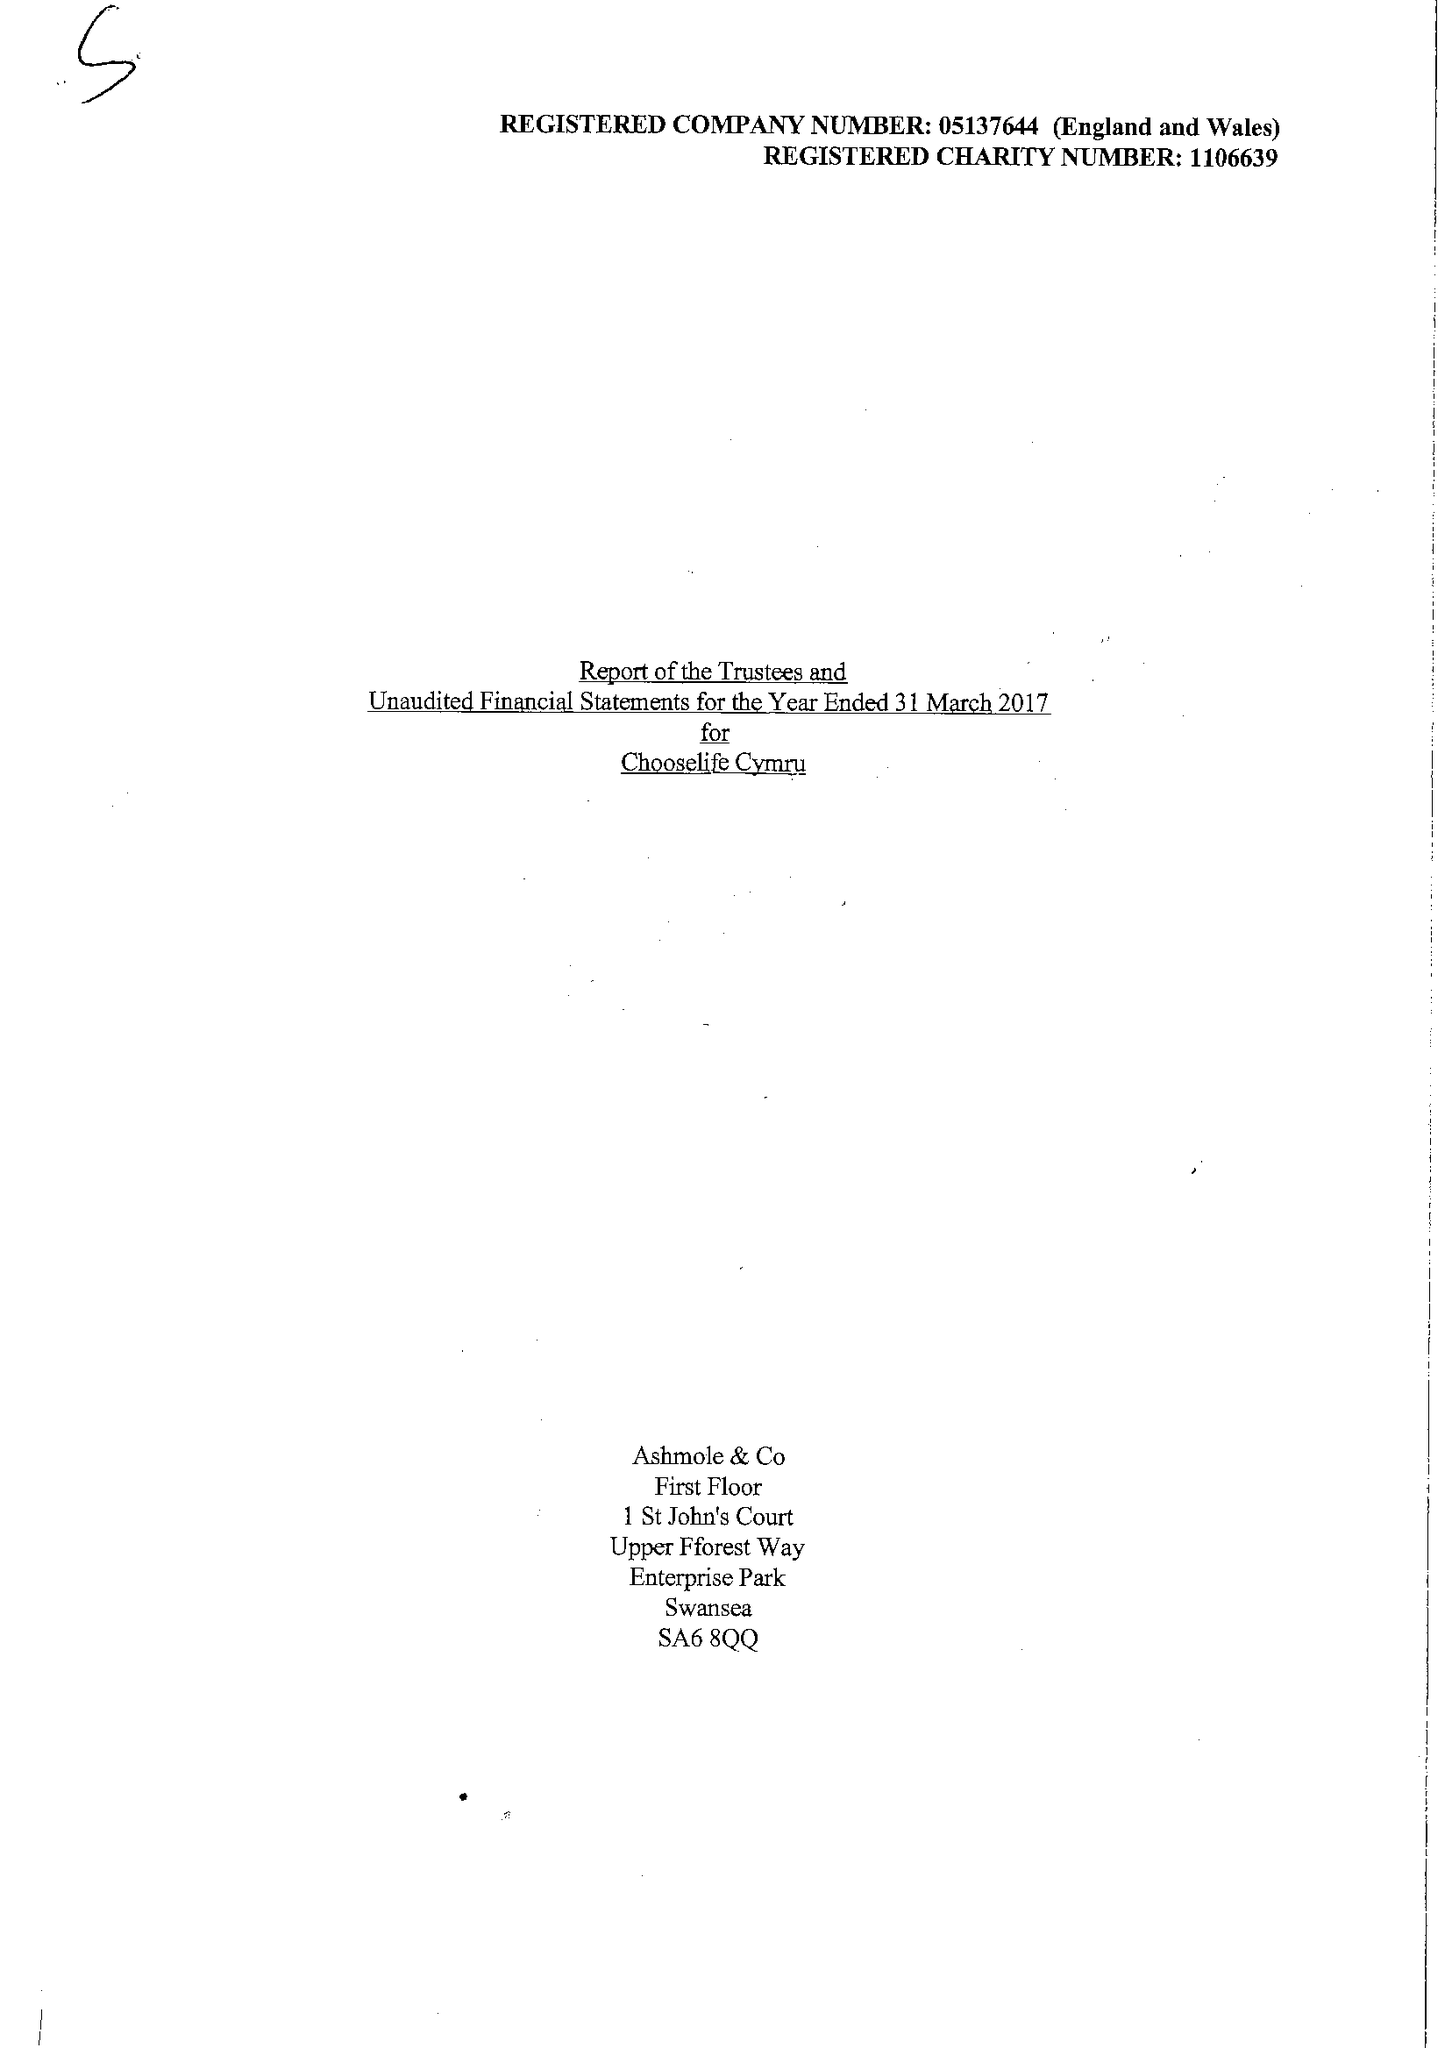What is the value for the address__post_town?
Answer the question using a single word or phrase. LLANELLI 